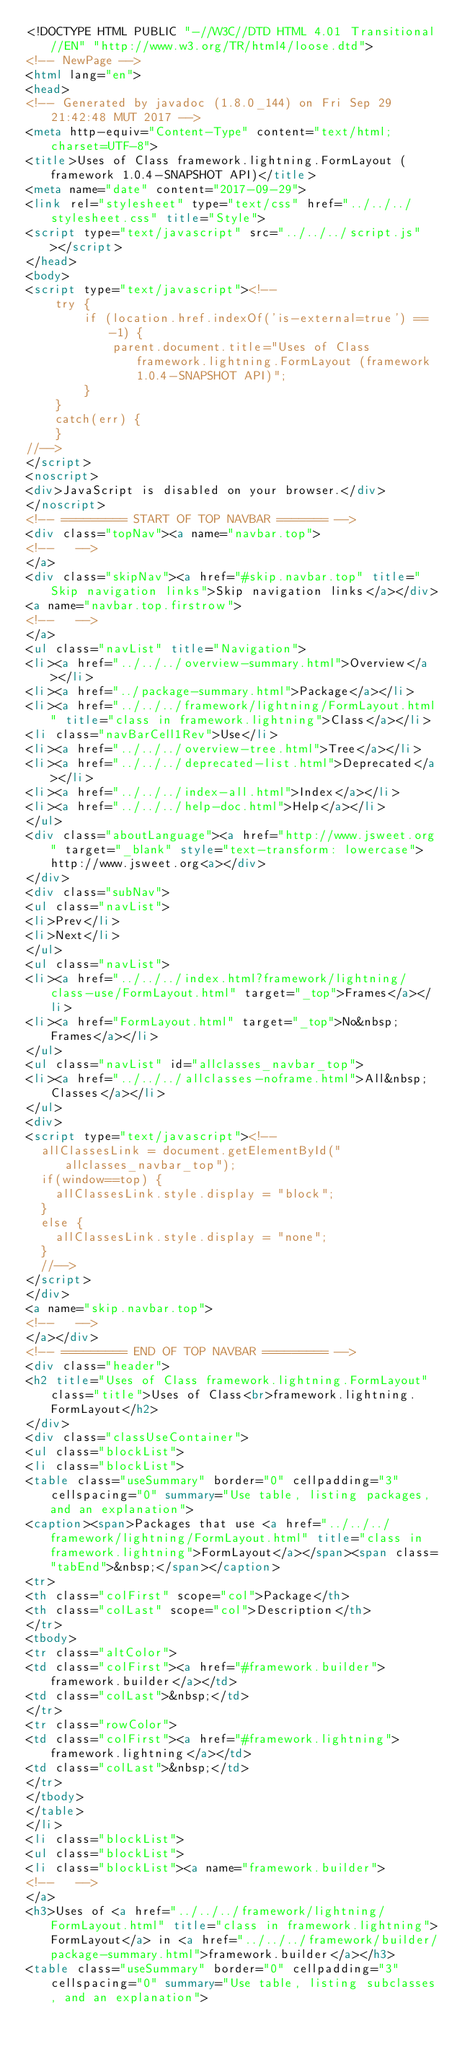<code> <loc_0><loc_0><loc_500><loc_500><_HTML_><!DOCTYPE HTML PUBLIC "-//W3C//DTD HTML 4.01 Transitional//EN" "http://www.w3.org/TR/html4/loose.dtd">
<!-- NewPage -->
<html lang="en">
<head>
<!-- Generated by javadoc (1.8.0_144) on Fri Sep 29 21:42:48 MUT 2017 -->
<meta http-equiv="Content-Type" content="text/html; charset=UTF-8">
<title>Uses of Class framework.lightning.FormLayout (framework 1.0.4-SNAPSHOT API)</title>
<meta name="date" content="2017-09-29">
<link rel="stylesheet" type="text/css" href="../../../stylesheet.css" title="Style">
<script type="text/javascript" src="../../../script.js"></script>
</head>
<body>
<script type="text/javascript"><!--
    try {
        if (location.href.indexOf('is-external=true') == -1) {
            parent.document.title="Uses of Class framework.lightning.FormLayout (framework 1.0.4-SNAPSHOT API)";
        }
    }
    catch(err) {
    }
//-->
</script>
<noscript>
<div>JavaScript is disabled on your browser.</div>
</noscript>
<!-- ========= START OF TOP NAVBAR ======= -->
<div class="topNav"><a name="navbar.top">
<!--   -->
</a>
<div class="skipNav"><a href="#skip.navbar.top" title="Skip navigation links">Skip navigation links</a></div>
<a name="navbar.top.firstrow">
<!--   -->
</a>
<ul class="navList" title="Navigation">
<li><a href="../../../overview-summary.html">Overview</a></li>
<li><a href="../package-summary.html">Package</a></li>
<li><a href="../../../framework/lightning/FormLayout.html" title="class in framework.lightning">Class</a></li>
<li class="navBarCell1Rev">Use</li>
<li><a href="../../../overview-tree.html">Tree</a></li>
<li><a href="../../../deprecated-list.html">Deprecated</a></li>
<li><a href="../../../index-all.html">Index</a></li>
<li><a href="../../../help-doc.html">Help</a></li>
</ul>
<div class="aboutLanguage"><a href="http://www.jsweet.org" target="_blank" style="text-transform: lowercase">http://www.jsweet.org<a></div>
</div>
<div class="subNav">
<ul class="navList">
<li>Prev</li>
<li>Next</li>
</ul>
<ul class="navList">
<li><a href="../../../index.html?framework/lightning/class-use/FormLayout.html" target="_top">Frames</a></li>
<li><a href="FormLayout.html" target="_top">No&nbsp;Frames</a></li>
</ul>
<ul class="navList" id="allclasses_navbar_top">
<li><a href="../../../allclasses-noframe.html">All&nbsp;Classes</a></li>
</ul>
<div>
<script type="text/javascript"><!--
  allClassesLink = document.getElementById("allclasses_navbar_top");
  if(window==top) {
    allClassesLink.style.display = "block";
  }
  else {
    allClassesLink.style.display = "none";
  }
  //-->
</script>
</div>
<a name="skip.navbar.top">
<!--   -->
</a></div>
<!-- ========= END OF TOP NAVBAR ========= -->
<div class="header">
<h2 title="Uses of Class framework.lightning.FormLayout" class="title">Uses of Class<br>framework.lightning.FormLayout</h2>
</div>
<div class="classUseContainer">
<ul class="blockList">
<li class="blockList">
<table class="useSummary" border="0" cellpadding="3" cellspacing="0" summary="Use table, listing packages, and an explanation">
<caption><span>Packages that use <a href="../../../framework/lightning/FormLayout.html" title="class in framework.lightning">FormLayout</a></span><span class="tabEnd">&nbsp;</span></caption>
<tr>
<th class="colFirst" scope="col">Package</th>
<th class="colLast" scope="col">Description</th>
</tr>
<tbody>
<tr class="altColor">
<td class="colFirst"><a href="#framework.builder">framework.builder</a></td>
<td class="colLast">&nbsp;</td>
</tr>
<tr class="rowColor">
<td class="colFirst"><a href="#framework.lightning">framework.lightning</a></td>
<td class="colLast">&nbsp;</td>
</tr>
</tbody>
</table>
</li>
<li class="blockList">
<ul class="blockList">
<li class="blockList"><a name="framework.builder">
<!--   -->
</a>
<h3>Uses of <a href="../../../framework/lightning/FormLayout.html" title="class in framework.lightning">FormLayout</a> in <a href="../../../framework/builder/package-summary.html">framework.builder</a></h3>
<table class="useSummary" border="0" cellpadding="3" cellspacing="0" summary="Use table, listing subclasses, and an explanation"></code> 